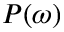<formula> <loc_0><loc_0><loc_500><loc_500>P ( \omega )</formula> 